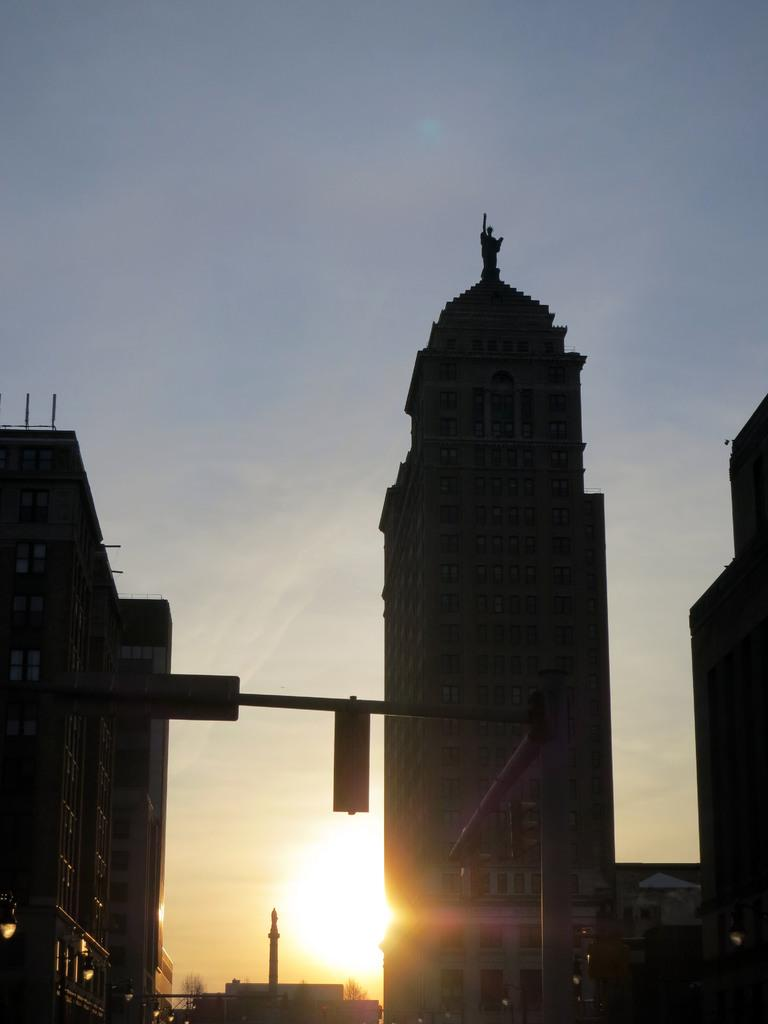What structures can be seen in the image? There are buildings in the image. Is there any specific feature on top of one of the buildings? Yes, there is a statue on top of a building. What can be seen in the background of the image? The sky is visible in the background of the image. How many ants are crawling on the statue in the image? There are no ants present in the image; the statue is on top of a building. 